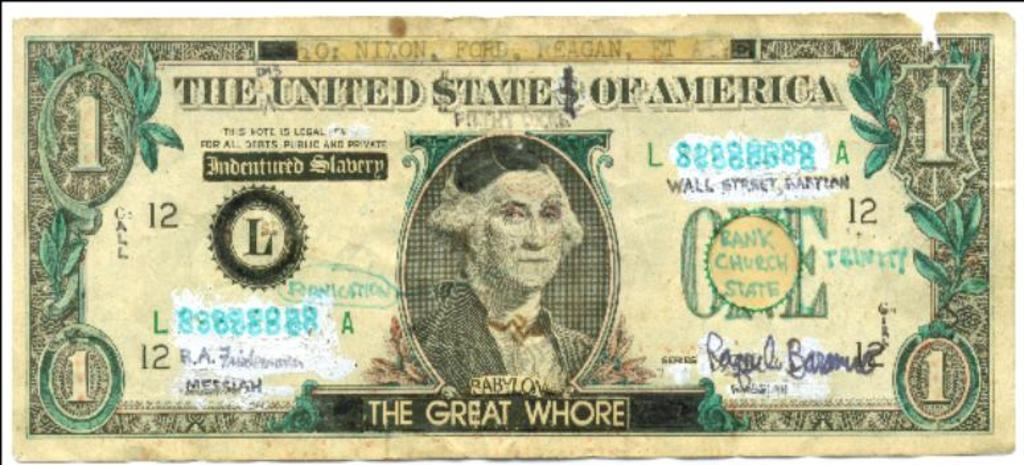<image>
Describe the image concisely. A one dollar bill from the United States of America. 